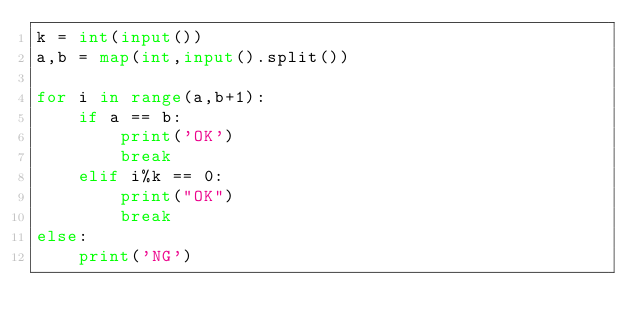<code> <loc_0><loc_0><loc_500><loc_500><_Python_>k = int(input())
a,b = map(int,input().split())

for i in range(a,b+1):
    if a == b:
        print('OK')
        break
    elif i%k == 0:
        print("OK")
        break
else:
    print('NG')
</code> 